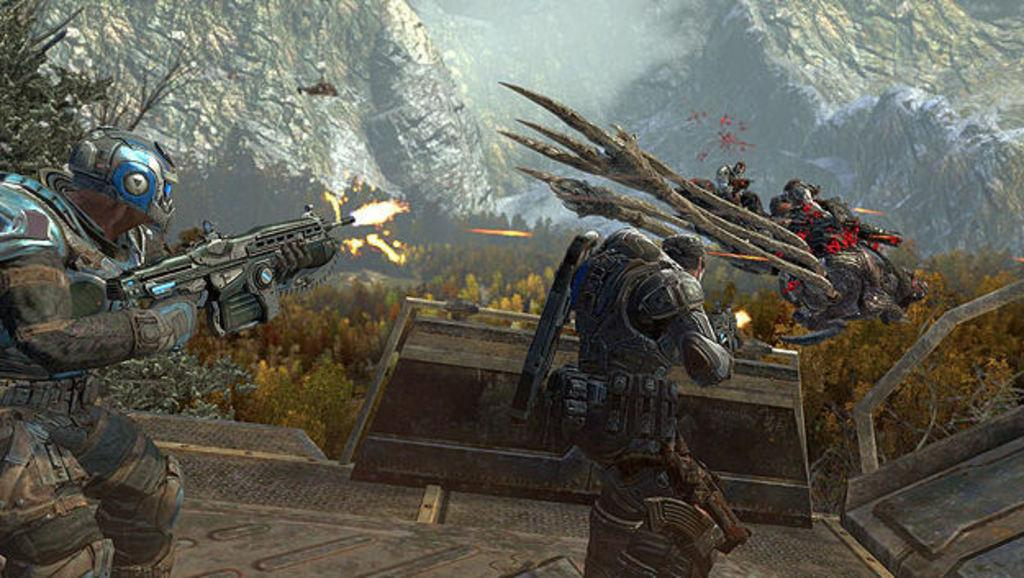What type of image is being described? The image is an animation. What are the people in the image holding? The people in the image are holding rifles. What kind of character or being is present in the image? There is a creature in the image. What can be seen in the distance in the image? There are hills and trees in the background of the image. How does the creature express regret in the image? The image does not show the creature expressing regret, as it is an animation and not a live-action scene. 